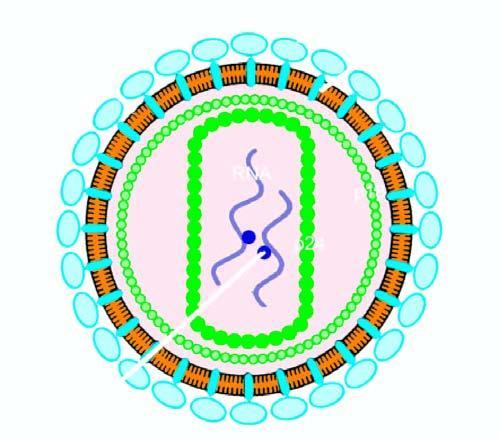what does the particle have containing proteins, p24 and p18, two strands of viral rna, and enzyme reverse transcriptase?
Answer the question using a single word or phrase. Core transcriptase 